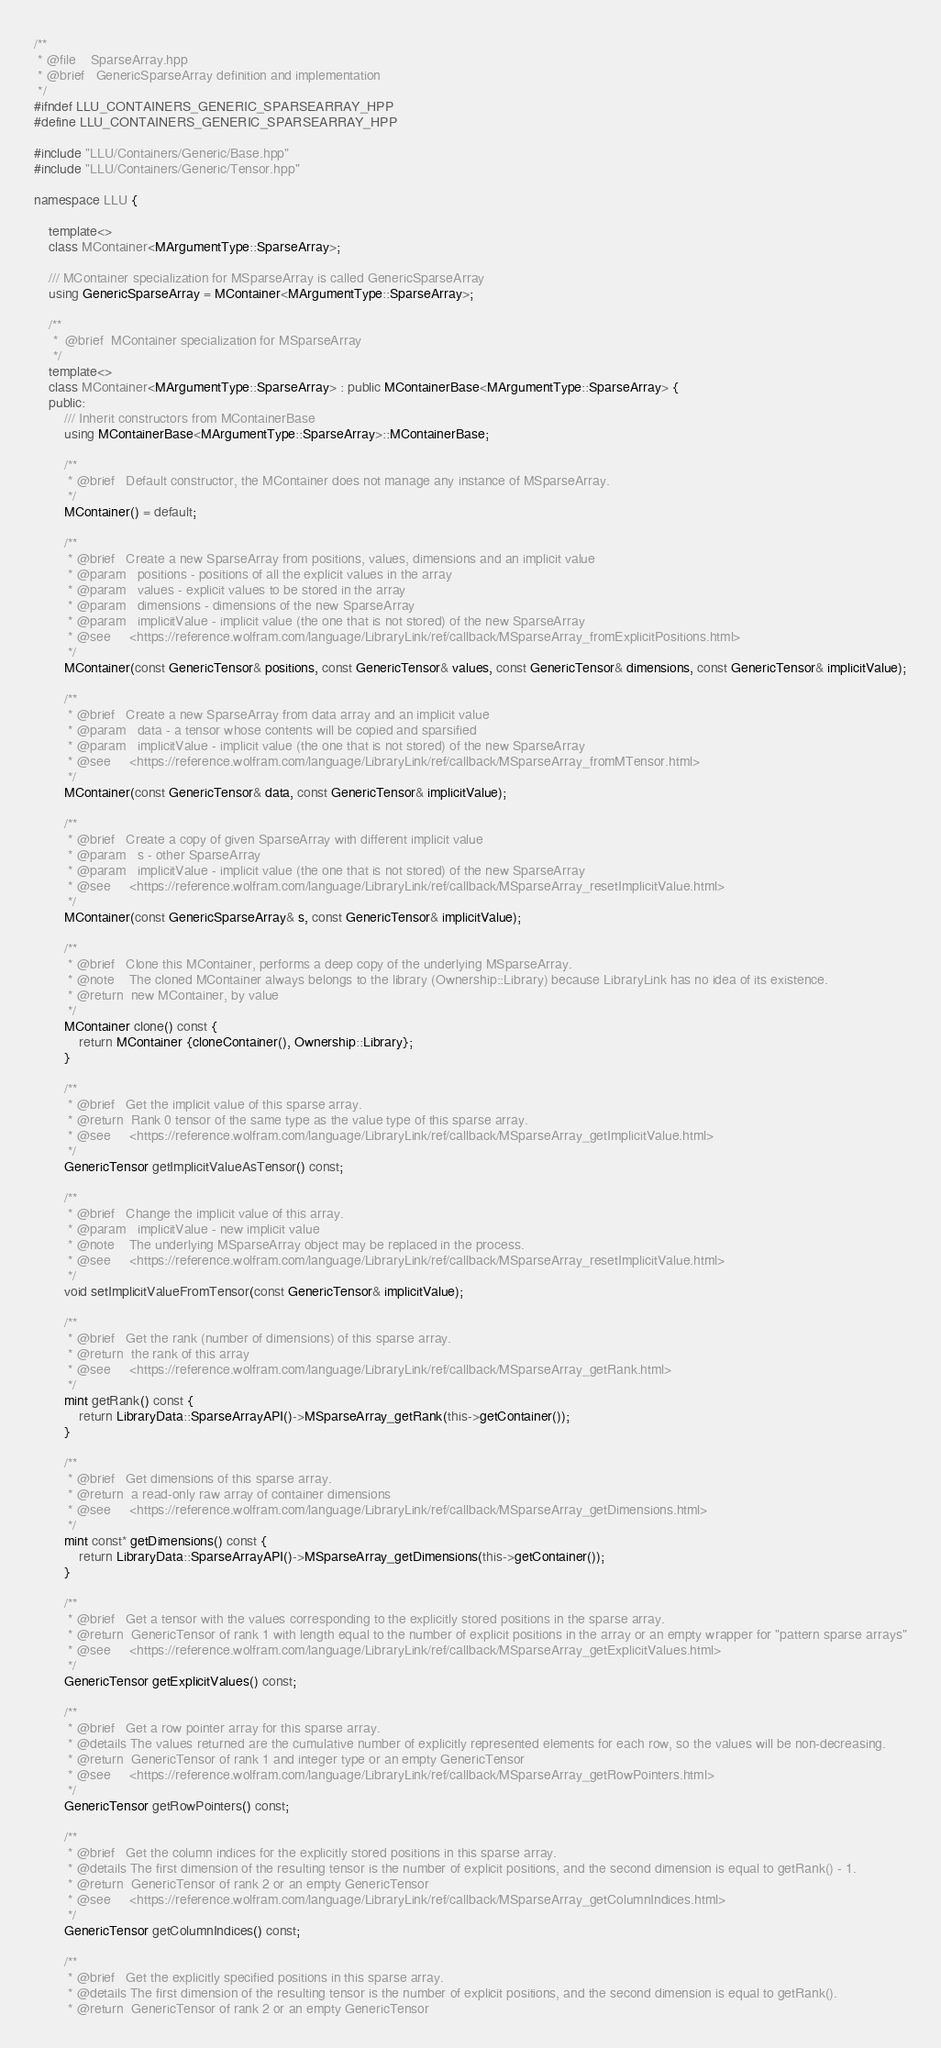<code> <loc_0><loc_0><loc_500><loc_500><_C++_>/**
 * @file    SparseArray.hpp
 * @brief   GenericSparseArray definition and implementation
 */
#ifndef LLU_CONTAINERS_GENERIC_SPARSEARRAY_HPP
#define LLU_CONTAINERS_GENERIC_SPARSEARRAY_HPP

#include "LLU/Containers/Generic/Base.hpp"
#include "LLU/Containers/Generic/Tensor.hpp"

namespace LLU {

	template<>
	class MContainer<MArgumentType::SparseArray>;

	/// MContainer specialization for MSparseArray is called GenericSparseArray
	using GenericSparseArray = MContainer<MArgumentType::SparseArray>;

	/**
	 *  @brief  MContainer specialization for MSparseArray
	 */
	template<>
	class MContainer<MArgumentType::SparseArray> : public MContainerBase<MArgumentType::SparseArray> {
	public:
		/// Inherit constructors from MContainerBase
		using MContainerBase<MArgumentType::SparseArray>::MContainerBase;

		/**
		 * @brief   Default constructor, the MContainer does not manage any instance of MSparseArray.
		 */
		MContainer() = default;

		/**
		 * @brief   Create a new SparseArray from positions, values, dimensions and an implicit value
		 * @param   positions - positions of all the explicit values in the array
		 * @param   values - explicit values to be stored in the array
		 * @param   dimensions - dimensions of the new SparseArray
		 * @param   implicitValue - implicit value (the one that is not stored) of the new SparseArray
		 * @see     <https://reference.wolfram.com/language/LibraryLink/ref/callback/MSparseArray_fromExplicitPositions.html>
		 */
		MContainer(const GenericTensor& positions, const GenericTensor& values, const GenericTensor& dimensions, const GenericTensor& implicitValue);

		/**
		 * @brief   Create a new SparseArray from data array and an implicit value
		 * @param   data - a tensor whose contents will be copied and sparsified
		 * @param   implicitValue - implicit value (the one that is not stored) of the new SparseArray
		 * @see     <https://reference.wolfram.com/language/LibraryLink/ref/callback/MSparseArray_fromMTensor.html>
		 */
		MContainer(const GenericTensor& data, const GenericTensor& implicitValue);

		/**
		 * @brief   Create a copy of given SparseArray with different implicit value
		 * @param   s - other SparseArray
		 * @param   implicitValue - implicit value (the one that is not stored) of the new SparseArray
		 * @see     <https://reference.wolfram.com/language/LibraryLink/ref/callback/MSparseArray_resetImplicitValue.html>
		 */
		MContainer(const GenericSparseArray& s, const GenericTensor& implicitValue);

		/**
		 * @brief   Clone this MContainer, performs a deep copy of the underlying MSparseArray.
		 * @note    The cloned MContainer always belongs to the library (Ownership::Library) because LibraryLink has no idea of its existence.
		 * @return  new MContainer, by value
		 */
		MContainer clone() const {
			return MContainer {cloneContainer(), Ownership::Library};
		}

		/**
		 * @brief   Get the implicit value of this sparse array.
		 * @return  Rank 0 tensor of the same type as the value type of this sparse array.
		 * @see     <https://reference.wolfram.com/language/LibraryLink/ref/callback/MSparseArray_getImplicitValue.html>
		 */
		GenericTensor getImplicitValueAsTensor() const;

		/**
		 * @brief   Change the implicit value of this array.
		 * @param   implicitValue - new implicit value
		 * @note    The underlying MSparseArray object may be replaced in the process.
		 * @see     <https://reference.wolfram.com/language/LibraryLink/ref/callback/MSparseArray_resetImplicitValue.html>
		 */
		void setImplicitValueFromTensor(const GenericTensor& implicitValue);

		/**
		 * @brief   Get the rank (number of dimensions) of this sparse array.
		 * @return  the rank of this array
		 * @see     <https://reference.wolfram.com/language/LibraryLink/ref/callback/MSparseArray_getRank.html>
		 */
		mint getRank() const {
			return LibraryData::SparseArrayAPI()->MSparseArray_getRank(this->getContainer());
		}

		/**
		 * @brief   Get dimensions of this sparse array.
		 * @return  a read-only raw array of container dimensions
		 * @see     <https://reference.wolfram.com/language/LibraryLink/ref/callback/MSparseArray_getDimensions.html>
		 */
		mint const* getDimensions() const {
			return LibraryData::SparseArrayAPI()->MSparseArray_getDimensions(this->getContainer());
		}

		/**
		 * @brief   Get a tensor with the values corresponding to the explicitly stored positions in the sparse array.
		 * @return  GenericTensor of rank 1 with length equal to the number of explicit positions in the array or an empty wrapper for "pattern sparse arrays"
		 * @see     <https://reference.wolfram.com/language/LibraryLink/ref/callback/MSparseArray_getExplicitValues.html>
		 */
		GenericTensor getExplicitValues() const;

		/**
		 * @brief   Get a row pointer array for this sparse array.
		 * @details The values returned are the cumulative number of explicitly represented elements for each row, so the values will be non-decreasing.
		 * @return  GenericTensor of rank 1 and integer type or an empty GenericTensor
		 * @see     <https://reference.wolfram.com/language/LibraryLink/ref/callback/MSparseArray_getRowPointers.html>
		 */
		GenericTensor getRowPointers() const;

		/**
		 * @brief   Get the column indices for the explicitly stored positions in this sparse array.
		 * @details The first dimension of the resulting tensor is the number of explicit positions, and the second dimension is equal to getRank() - 1.
		 * @return  GenericTensor of rank 2 or an empty GenericTensor
		 * @see     <https://reference.wolfram.com/language/LibraryLink/ref/callback/MSparseArray_getColumnIndices.html>
		 */
		GenericTensor getColumnIndices() const;

		/**
		 * @brief   Get the explicitly specified positions in this sparse array.
		 * @details The first dimension of the resulting tensor is the number of explicit positions, and the second dimension is equal to getRank().
		 * @return  GenericTensor of rank 2 or an empty GenericTensor</code> 